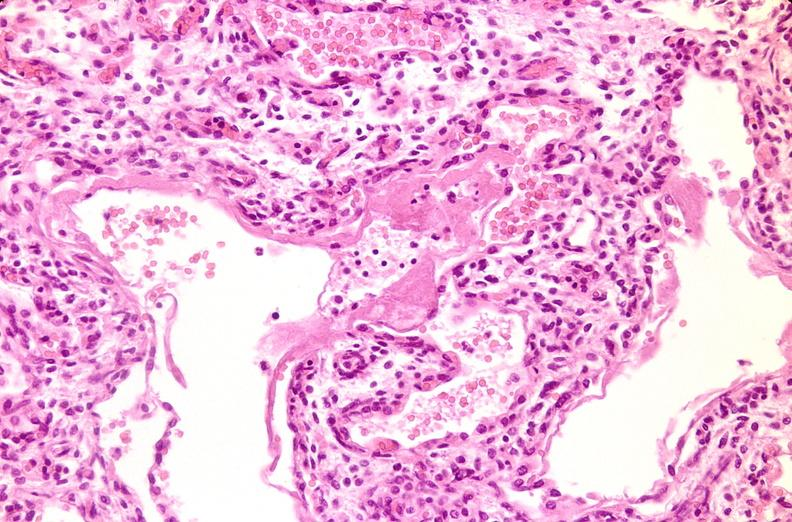what does this image show?
Answer the question using a single word or phrase. Lungs 